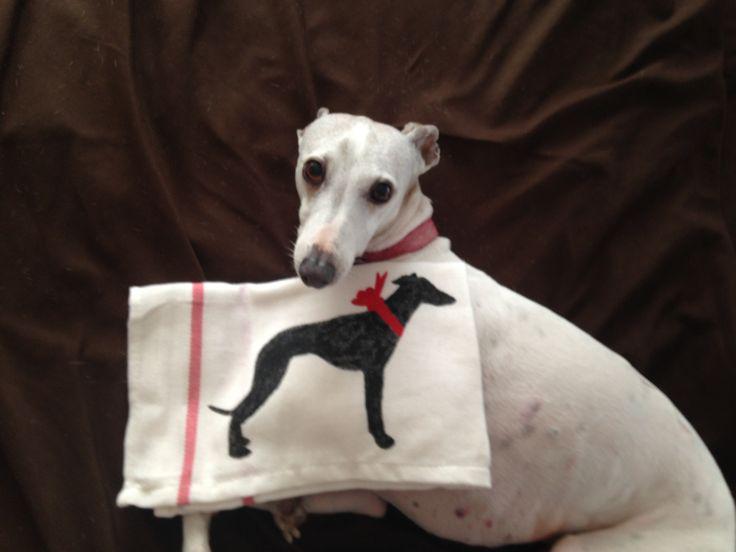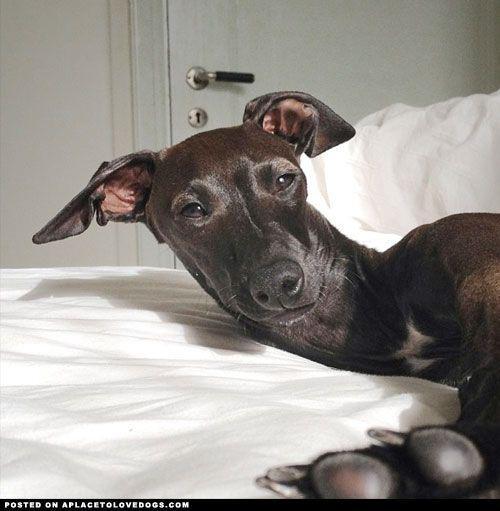The first image is the image on the left, the second image is the image on the right. Given the left and right images, does the statement "One image shows one brown dog reclining, and the other image features a hound wearing a collar." hold true? Answer yes or no. Yes. 